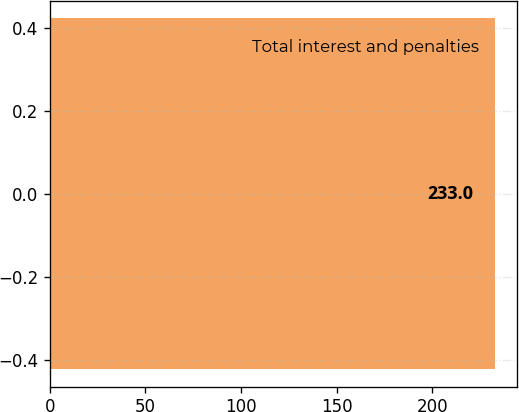Convert chart to OTSL. <chart><loc_0><loc_0><loc_500><loc_500><bar_chart><fcel>Total interest and penalties<nl><fcel>233<nl></chart> 